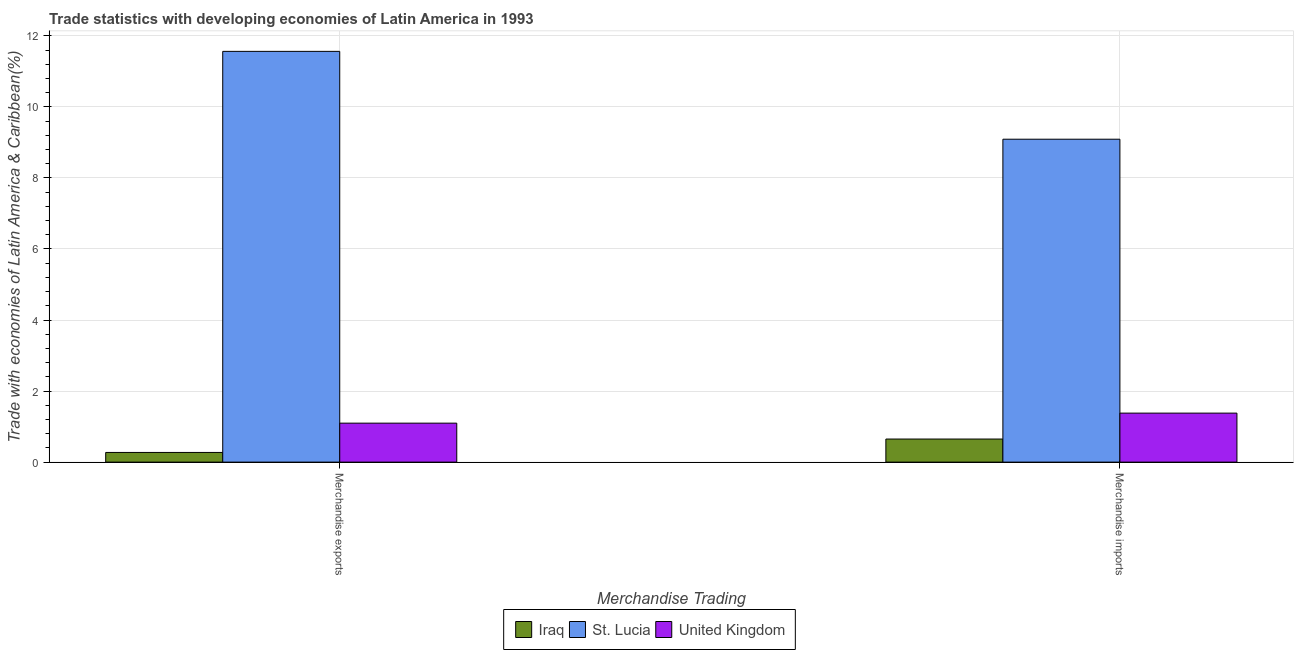How many different coloured bars are there?
Your answer should be very brief. 3. How many groups of bars are there?
Your answer should be very brief. 2. How many bars are there on the 2nd tick from the left?
Keep it short and to the point. 3. How many bars are there on the 1st tick from the right?
Make the answer very short. 3. What is the merchandise exports in United Kingdom?
Your answer should be very brief. 1.1. Across all countries, what is the maximum merchandise imports?
Provide a succinct answer. 9.09. Across all countries, what is the minimum merchandise imports?
Your answer should be very brief. 0.65. In which country was the merchandise imports maximum?
Provide a succinct answer. St. Lucia. In which country was the merchandise imports minimum?
Offer a terse response. Iraq. What is the total merchandise imports in the graph?
Offer a very short reply. 11.12. What is the difference between the merchandise exports in St. Lucia and that in Iraq?
Your response must be concise. 11.29. What is the difference between the merchandise imports in United Kingdom and the merchandise exports in St. Lucia?
Your answer should be compact. -10.18. What is the average merchandise imports per country?
Your answer should be very brief. 3.71. What is the difference between the merchandise imports and merchandise exports in St. Lucia?
Your answer should be compact. -2.47. In how many countries, is the merchandise imports greater than 2.8 %?
Provide a short and direct response. 1. What is the ratio of the merchandise exports in St. Lucia to that in United Kingdom?
Ensure brevity in your answer.  10.54. What does the 2nd bar from the left in Merchandise imports represents?
Your answer should be very brief. St. Lucia. How many bars are there?
Provide a short and direct response. 6. How many countries are there in the graph?
Provide a succinct answer. 3. Does the graph contain any zero values?
Offer a terse response. No. What is the title of the graph?
Offer a terse response. Trade statistics with developing economies of Latin America in 1993. Does "Canada" appear as one of the legend labels in the graph?
Keep it short and to the point. No. What is the label or title of the X-axis?
Your response must be concise. Merchandise Trading. What is the label or title of the Y-axis?
Provide a short and direct response. Trade with economies of Latin America & Caribbean(%). What is the Trade with economies of Latin America & Caribbean(%) in Iraq in Merchandise exports?
Offer a very short reply. 0.27. What is the Trade with economies of Latin America & Caribbean(%) in St. Lucia in Merchandise exports?
Ensure brevity in your answer.  11.56. What is the Trade with economies of Latin America & Caribbean(%) of United Kingdom in Merchandise exports?
Provide a succinct answer. 1.1. What is the Trade with economies of Latin America & Caribbean(%) of Iraq in Merchandise imports?
Offer a very short reply. 0.65. What is the Trade with economies of Latin America & Caribbean(%) in St. Lucia in Merchandise imports?
Your answer should be very brief. 9.09. What is the Trade with economies of Latin America & Caribbean(%) in United Kingdom in Merchandise imports?
Your response must be concise. 1.38. Across all Merchandise Trading, what is the maximum Trade with economies of Latin America & Caribbean(%) in Iraq?
Make the answer very short. 0.65. Across all Merchandise Trading, what is the maximum Trade with economies of Latin America & Caribbean(%) of St. Lucia?
Make the answer very short. 11.56. Across all Merchandise Trading, what is the maximum Trade with economies of Latin America & Caribbean(%) in United Kingdom?
Provide a short and direct response. 1.38. Across all Merchandise Trading, what is the minimum Trade with economies of Latin America & Caribbean(%) in Iraq?
Keep it short and to the point. 0.27. Across all Merchandise Trading, what is the minimum Trade with economies of Latin America & Caribbean(%) of St. Lucia?
Give a very brief answer. 9.09. Across all Merchandise Trading, what is the minimum Trade with economies of Latin America & Caribbean(%) in United Kingdom?
Your answer should be very brief. 1.1. What is the total Trade with economies of Latin America & Caribbean(%) of Iraq in the graph?
Give a very brief answer. 0.92. What is the total Trade with economies of Latin America & Caribbean(%) in St. Lucia in the graph?
Your answer should be very brief. 20.65. What is the total Trade with economies of Latin America & Caribbean(%) in United Kingdom in the graph?
Your answer should be very brief. 2.48. What is the difference between the Trade with economies of Latin America & Caribbean(%) in Iraq in Merchandise exports and that in Merchandise imports?
Offer a very short reply. -0.38. What is the difference between the Trade with economies of Latin America & Caribbean(%) of St. Lucia in Merchandise exports and that in Merchandise imports?
Ensure brevity in your answer.  2.47. What is the difference between the Trade with economies of Latin America & Caribbean(%) of United Kingdom in Merchandise exports and that in Merchandise imports?
Your answer should be very brief. -0.28. What is the difference between the Trade with economies of Latin America & Caribbean(%) of Iraq in Merchandise exports and the Trade with economies of Latin America & Caribbean(%) of St. Lucia in Merchandise imports?
Your response must be concise. -8.82. What is the difference between the Trade with economies of Latin America & Caribbean(%) of Iraq in Merchandise exports and the Trade with economies of Latin America & Caribbean(%) of United Kingdom in Merchandise imports?
Offer a terse response. -1.11. What is the difference between the Trade with economies of Latin America & Caribbean(%) in St. Lucia in Merchandise exports and the Trade with economies of Latin America & Caribbean(%) in United Kingdom in Merchandise imports?
Give a very brief answer. 10.18. What is the average Trade with economies of Latin America & Caribbean(%) of Iraq per Merchandise Trading?
Keep it short and to the point. 0.46. What is the average Trade with economies of Latin America & Caribbean(%) of St. Lucia per Merchandise Trading?
Give a very brief answer. 10.33. What is the average Trade with economies of Latin America & Caribbean(%) of United Kingdom per Merchandise Trading?
Ensure brevity in your answer.  1.24. What is the difference between the Trade with economies of Latin America & Caribbean(%) in Iraq and Trade with economies of Latin America & Caribbean(%) in St. Lucia in Merchandise exports?
Provide a short and direct response. -11.29. What is the difference between the Trade with economies of Latin America & Caribbean(%) in Iraq and Trade with economies of Latin America & Caribbean(%) in United Kingdom in Merchandise exports?
Make the answer very short. -0.82. What is the difference between the Trade with economies of Latin America & Caribbean(%) in St. Lucia and Trade with economies of Latin America & Caribbean(%) in United Kingdom in Merchandise exports?
Your answer should be very brief. 10.47. What is the difference between the Trade with economies of Latin America & Caribbean(%) of Iraq and Trade with economies of Latin America & Caribbean(%) of St. Lucia in Merchandise imports?
Provide a short and direct response. -8.44. What is the difference between the Trade with economies of Latin America & Caribbean(%) of Iraq and Trade with economies of Latin America & Caribbean(%) of United Kingdom in Merchandise imports?
Provide a succinct answer. -0.73. What is the difference between the Trade with economies of Latin America & Caribbean(%) in St. Lucia and Trade with economies of Latin America & Caribbean(%) in United Kingdom in Merchandise imports?
Provide a short and direct response. 7.71. What is the ratio of the Trade with economies of Latin America & Caribbean(%) of Iraq in Merchandise exports to that in Merchandise imports?
Ensure brevity in your answer.  0.42. What is the ratio of the Trade with economies of Latin America & Caribbean(%) of St. Lucia in Merchandise exports to that in Merchandise imports?
Your answer should be compact. 1.27. What is the ratio of the Trade with economies of Latin America & Caribbean(%) in United Kingdom in Merchandise exports to that in Merchandise imports?
Provide a succinct answer. 0.8. What is the difference between the highest and the second highest Trade with economies of Latin America & Caribbean(%) of Iraq?
Provide a short and direct response. 0.38. What is the difference between the highest and the second highest Trade with economies of Latin America & Caribbean(%) in St. Lucia?
Your answer should be compact. 2.47. What is the difference between the highest and the second highest Trade with economies of Latin America & Caribbean(%) of United Kingdom?
Your answer should be very brief. 0.28. What is the difference between the highest and the lowest Trade with economies of Latin America & Caribbean(%) of Iraq?
Your answer should be very brief. 0.38. What is the difference between the highest and the lowest Trade with economies of Latin America & Caribbean(%) in St. Lucia?
Make the answer very short. 2.47. What is the difference between the highest and the lowest Trade with economies of Latin America & Caribbean(%) of United Kingdom?
Offer a terse response. 0.28. 